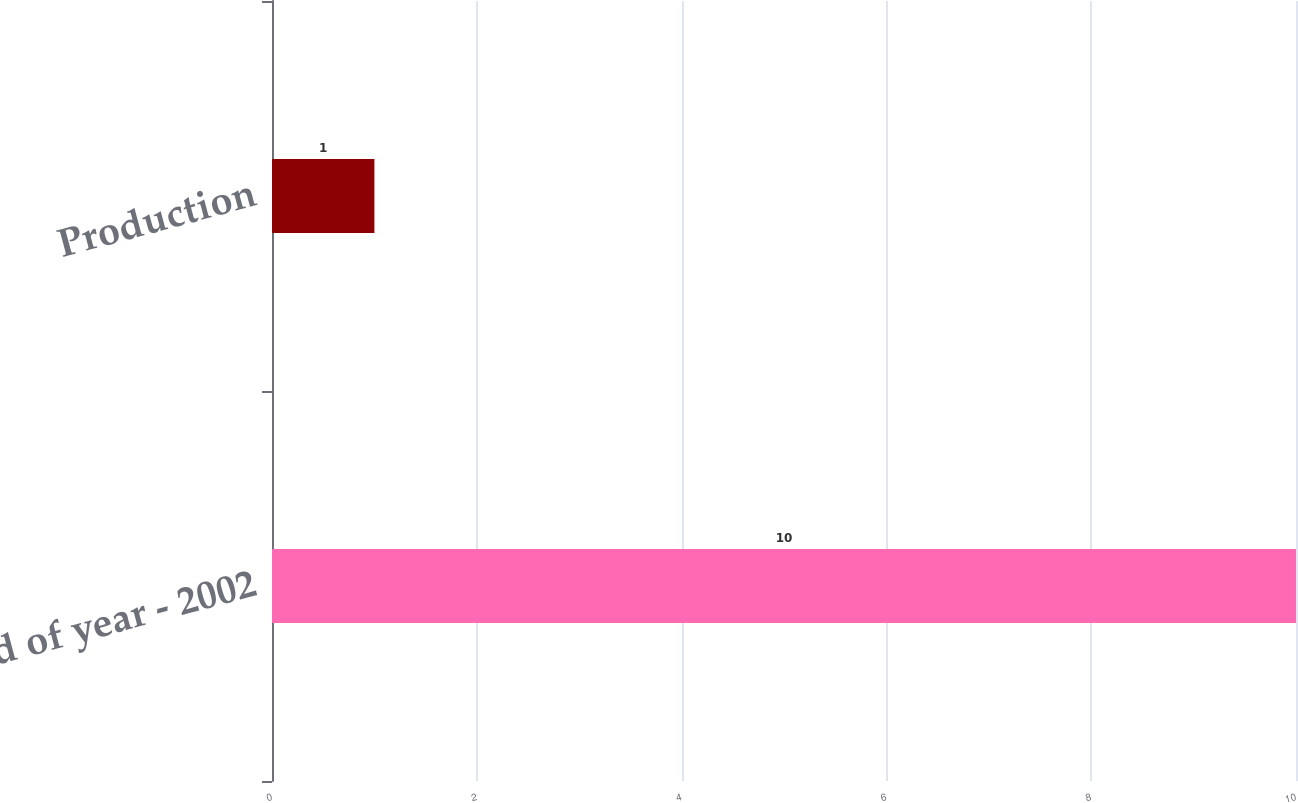Convert chart. <chart><loc_0><loc_0><loc_500><loc_500><bar_chart><fcel>End of year - 2002<fcel>Production<nl><fcel>10<fcel>1<nl></chart> 